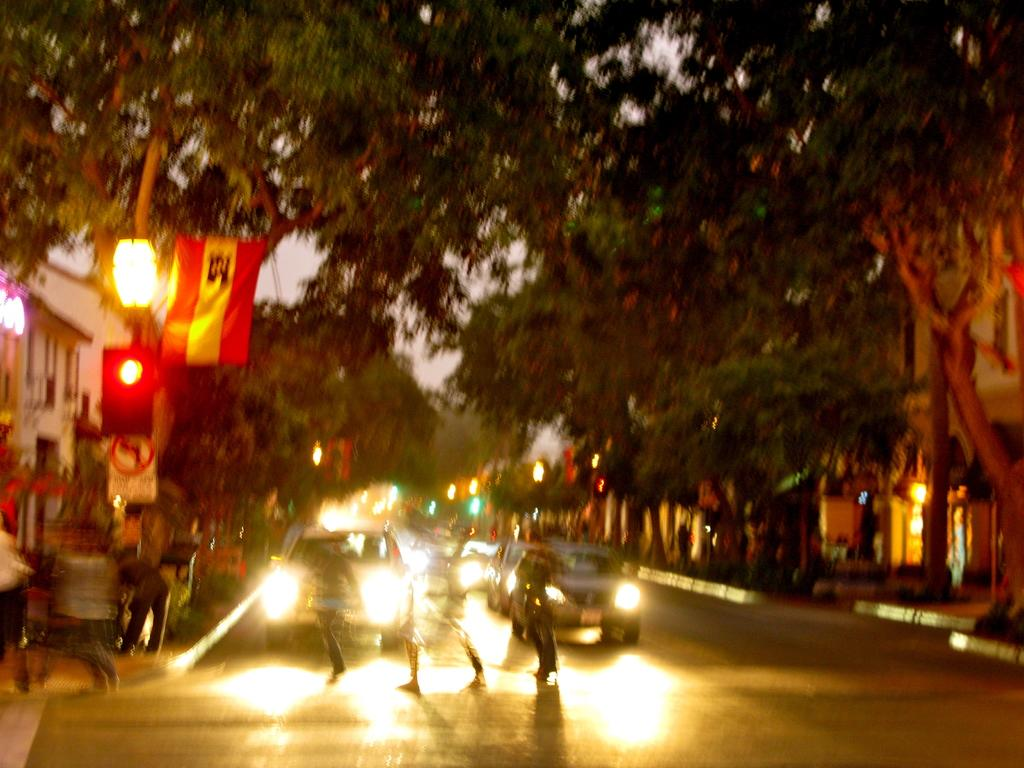What is the main subject in the foreground of the image? There is a crowd in the foreground of the image. What else can be seen in the foreground of the image? There are fleets of cars on the road in the foreground. What can be seen in the background of the image? There are trees, buildings, boards, and light poles in the background of the image. What time of day is the image taken? The image is taken during night. Who is the owner of the orange seen in the image? There is no orange present in the image. What type of uniform is the fireman wearing in the image? There is no fireman present in the image. 